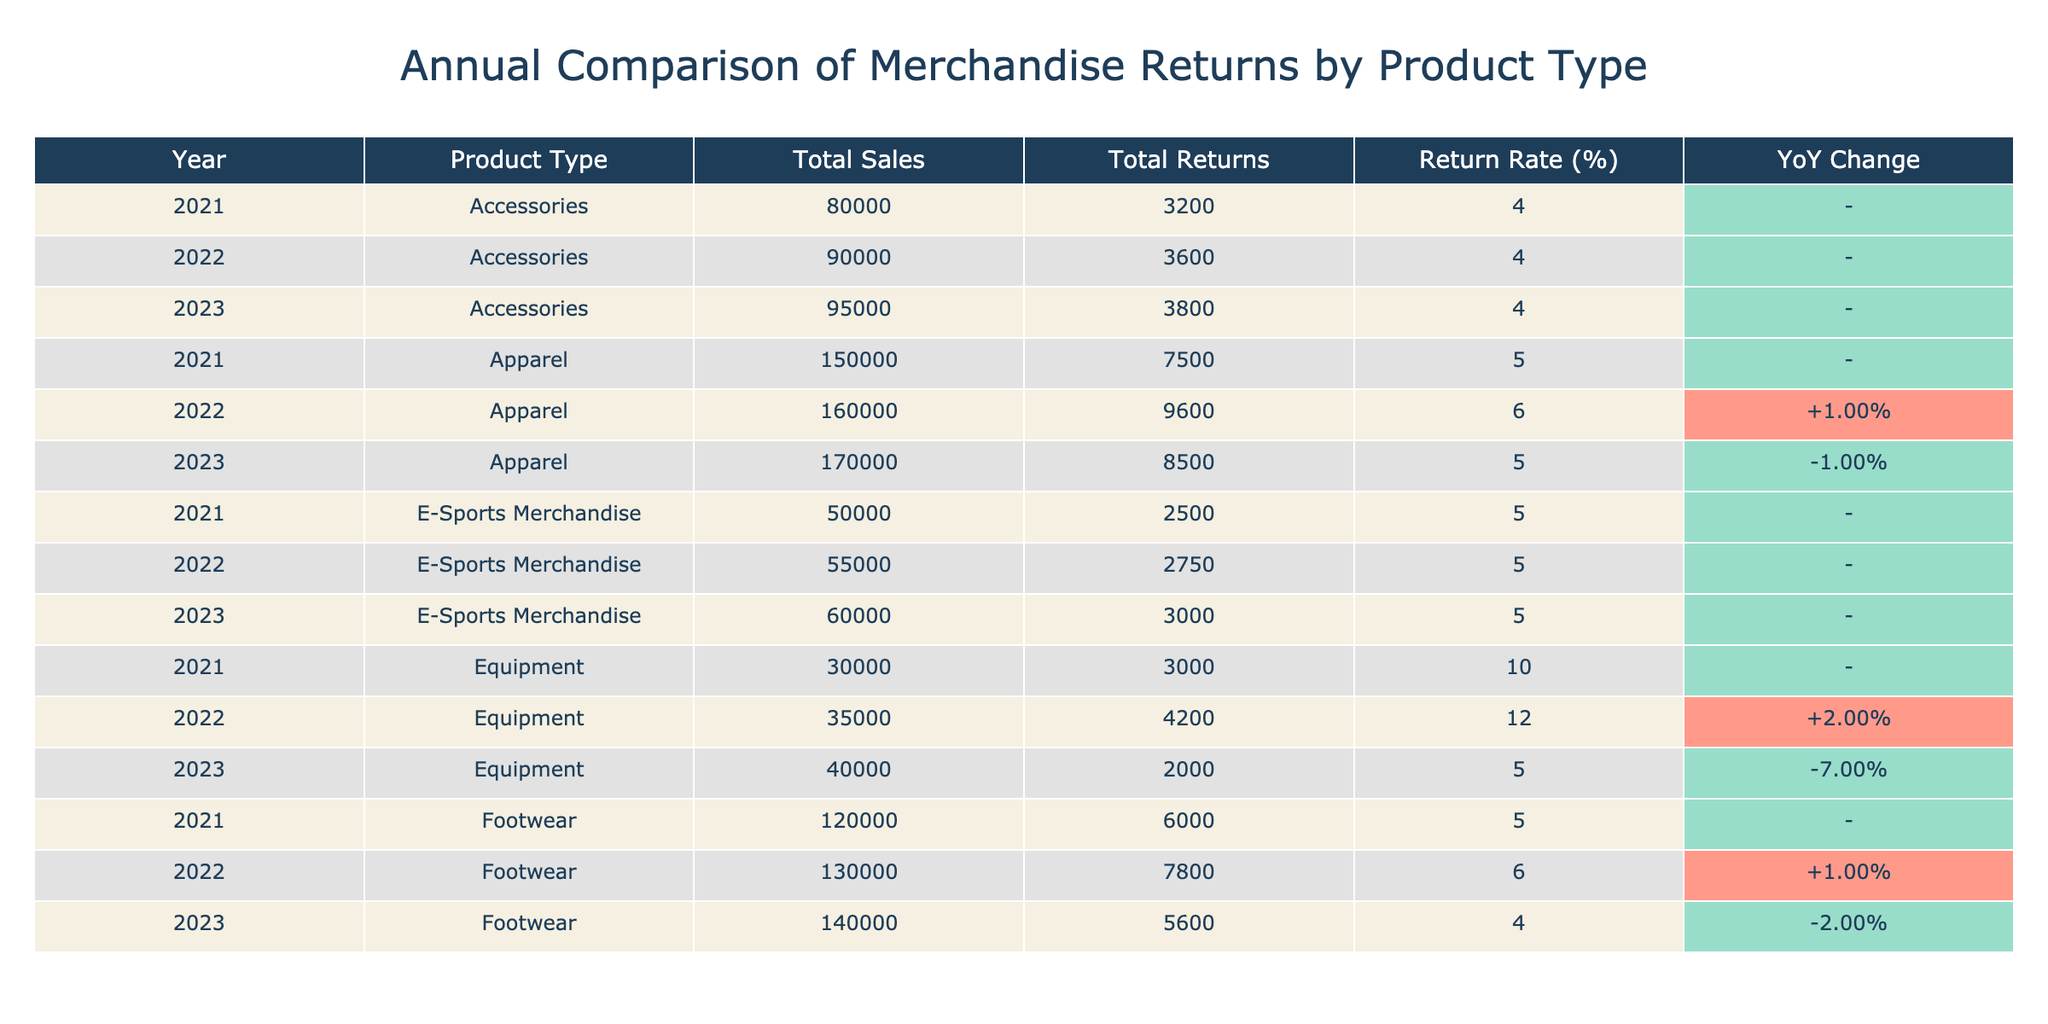What was the total sales for Apparel in 2022? In the row for the year 2022 and product type Apparel, it shows that the Total Sales amount is 160000.
Answer: 160000 What is the return rate for Footwear in 2023? In the row for the year 2023 and product type Footwear, the Return Rate is listed as 4.00%.
Answer: 4.00% Which product type had the highest total returns in 2021? Looking at the Total Returns column for the year 2021, Equipment had the highest returns with 3000.
Answer: Equipment What is the average return rate for Accessories over the three years? The return rates for Accessories are 4.00% in 2021, 4.00% in 2022, and 4.00% in 2023. Adding these gives 12.00%, and dividing by 3 gives an average of 4.00%.
Answer: 4.00% Did the return rate for Equipment increase from 2022 to 2023? The return rate for Equipment in 2022 is 12.00%, and in 2023 it decreased to 5.00%. Therefore, it did not increase.
Answer: No What was the difference in total sales between E-Sports Merchandise in 2021 and 2023? Total Sales for E-Sports Merchandise in 2021 is 50000, and in 2023 it is 60000. The difference is 60000 - 50000 = 10000.
Answer: 10000 Was the total sales figure for Accessories higher in 2023 compared to 2021? Total Sales for Accessories in 2021 was 80000, and in 2023 it was 95000. Since 95000 is greater than 80000, the sales figure was higher.
Answer: Yes Which product had the largest increase in return rate from 2021 to 2022? The return rate for Equipment increased from 10.00% in 2021 to 12.00% in 2022, making it an increase of 2.00%. This is the largest increase among all product types.
Answer: Equipment What was the total number of returns for Footwear across all three years? The total returns for Footwear are 6000 in 2021, 7800 in 2022, and 5600 in 2023. Adding these values gives 6000 + 7800 + 5600 = 19400 total returns.
Answer: 19400 